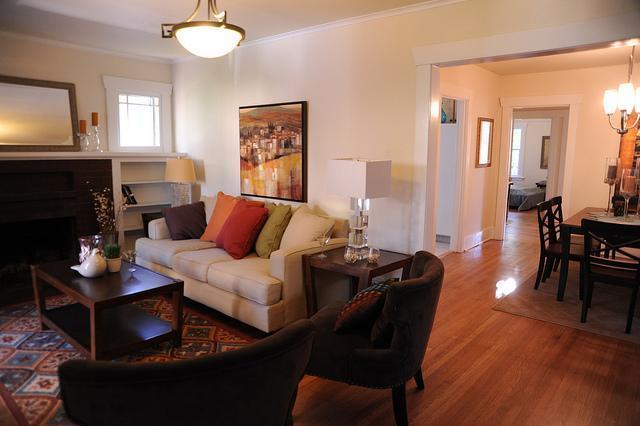How many different colors are the cushions on the couch?
Give a very brief answer. 5. How many chairs are pictured at the table?
Give a very brief answer. 3. How many chairs can be seen?
Give a very brief answer. 4. 